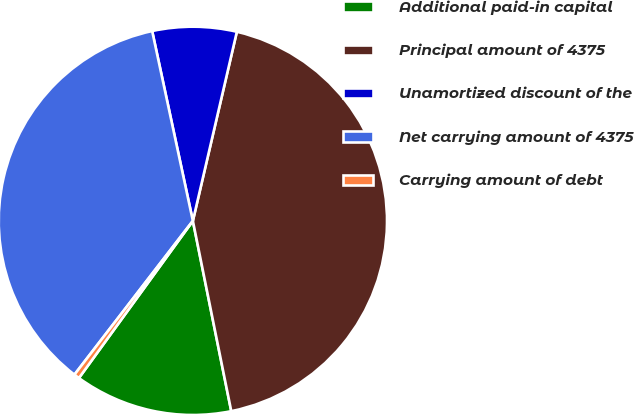Convert chart to OTSL. <chart><loc_0><loc_0><loc_500><loc_500><pie_chart><fcel>Additional paid-in capital<fcel>Principal amount of 4375<fcel>Unamortized discount of the<fcel>Net carrying amount of 4375<fcel>Carrying amount of debt<nl><fcel>13.15%<fcel>43.19%<fcel>7.0%<fcel>36.19%<fcel>0.46%<nl></chart> 